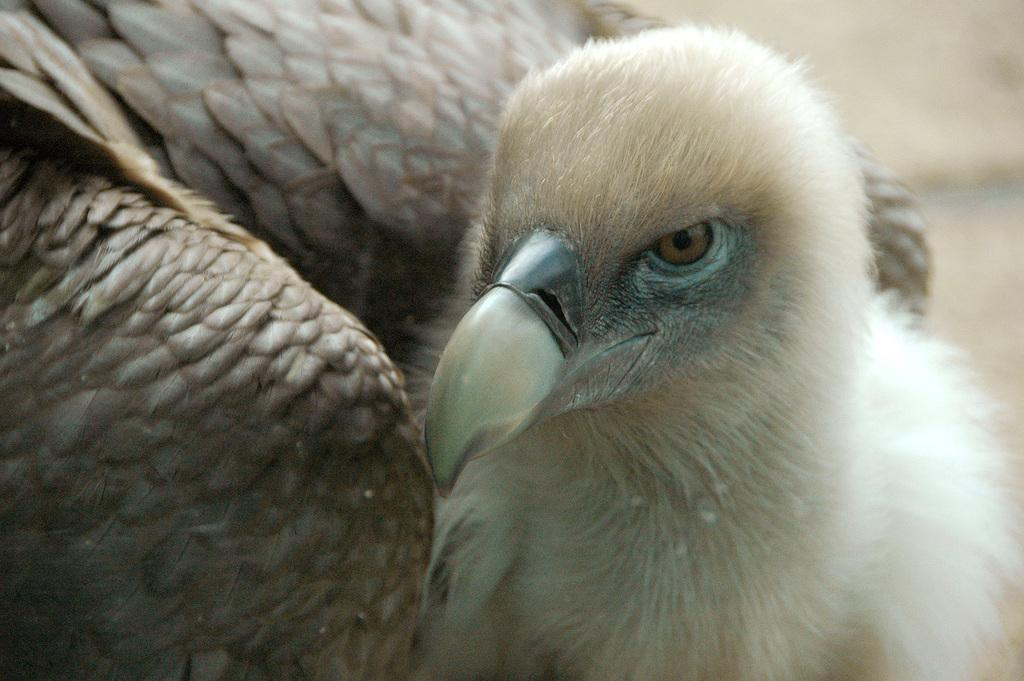What type of animal can be seen in the image? There is a bird in the image. What can be found on the left side of the image? There are bird feathers on the left side of the image. What type of organization is hosting the event in the image? There is no event or organization present in the image; it features a bird and bird feathers. Can you describe the trail that the bird is following in the image? There is no trail visible in the image, as it only shows a bird and bird feathers. 